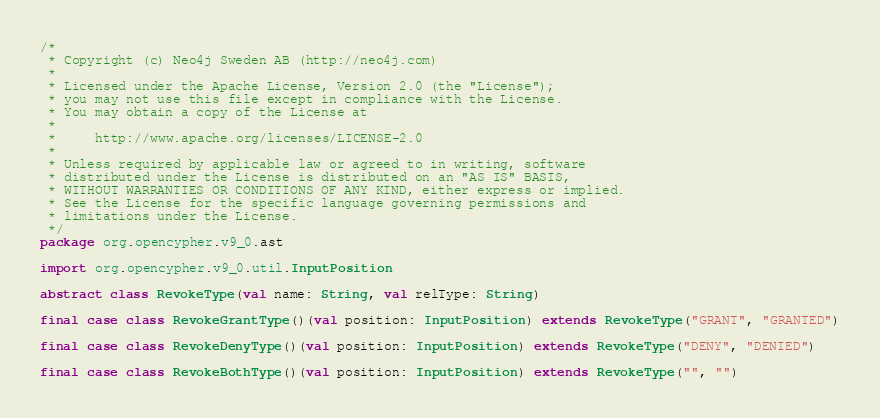Convert code to text. <code><loc_0><loc_0><loc_500><loc_500><_Scala_>/*
 * Copyright (c) Neo4j Sweden AB (http://neo4j.com)
 *
 * Licensed under the Apache License, Version 2.0 (the "License");
 * you may not use this file except in compliance with the License.
 * You may obtain a copy of the License at
 *
 *     http://www.apache.org/licenses/LICENSE-2.0
 *
 * Unless required by applicable law or agreed to in writing, software
 * distributed under the License is distributed on an "AS IS" BASIS,
 * WITHOUT WARRANTIES OR CONDITIONS OF ANY KIND, either express or implied.
 * See the License for the specific language governing permissions and
 * limitations under the License.
 */
package org.opencypher.v9_0.ast

import org.opencypher.v9_0.util.InputPosition

abstract class RevokeType(val name: String, val relType: String)

final case class RevokeGrantType()(val position: InputPosition) extends RevokeType("GRANT", "GRANTED")

final case class RevokeDenyType()(val position: InputPosition) extends RevokeType("DENY", "DENIED")

final case class RevokeBothType()(val position: InputPosition) extends RevokeType("", "")
</code> 